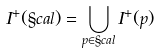<formula> <loc_0><loc_0><loc_500><loc_500>I ^ { + } ( \S c a l ) = \bigcup _ { p \in \S c a l } I ^ { + } ( p )</formula> 